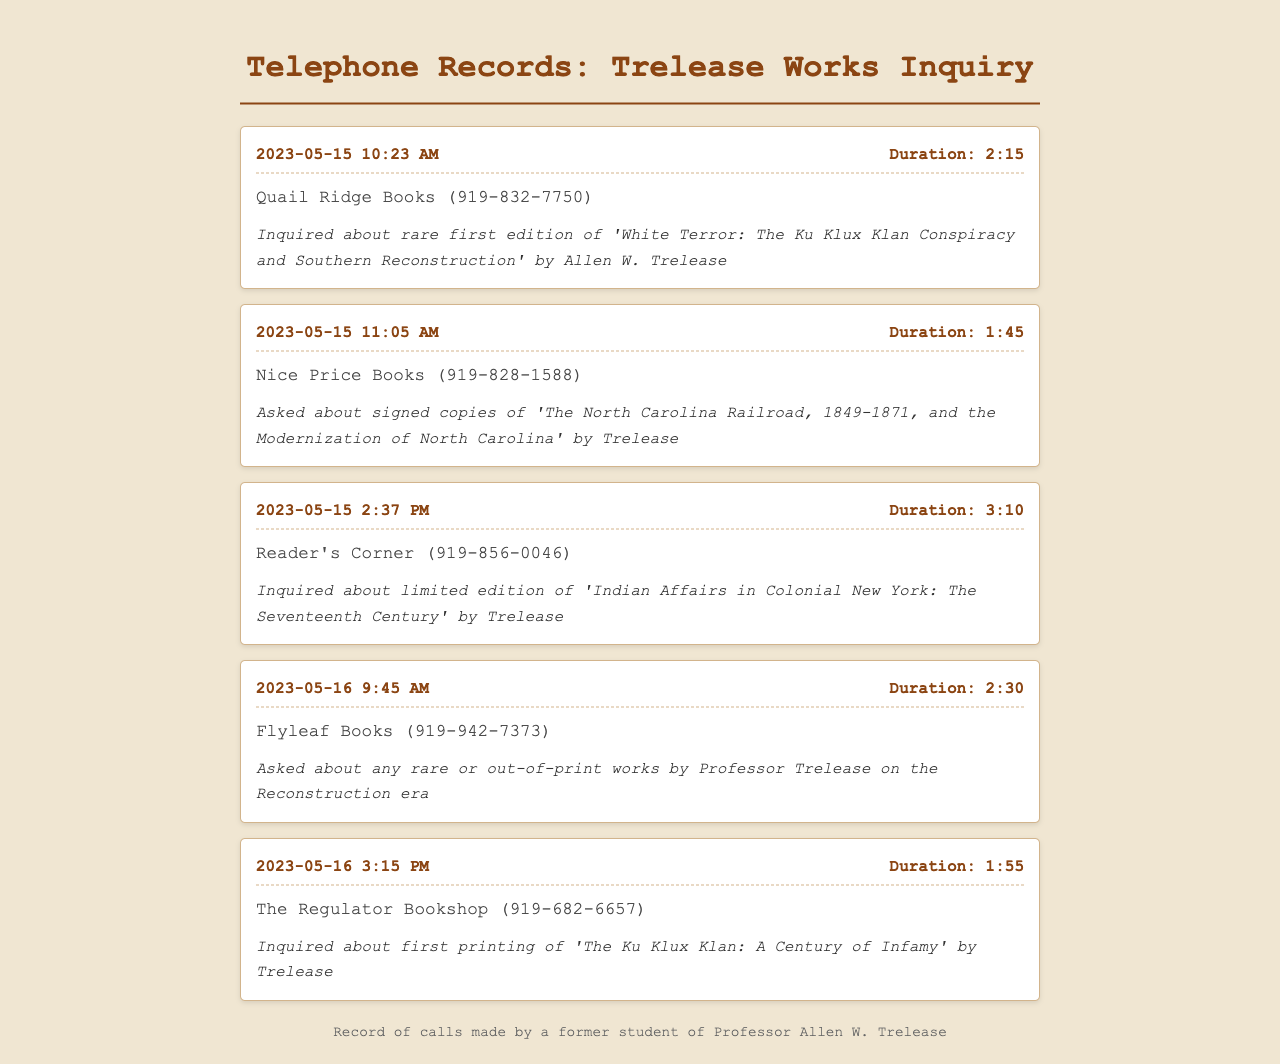What is the date of the first call? The first call listed in the telephone records is on May 15, 2023.
Answer: May 15, 2023 How long was the call to Quail Ridge Books? The duration of the call to Quail Ridge Books is captured in the record. It states the duration is 2 minutes and 15 seconds.
Answer: 2:15 Which bookstore was called last? The last entry in the telephone records indicates the final call made was to The Regulator Bookshop.
Answer: The Regulator Bookshop What was inquired about during the call to Flyleaf Books? The notes section of the Flyleaf Books entry specifies that a query was made about rare or out-of-print works by Professor Trelease.
Answer: Rare or out-of-print works How many calls were made on May 16, 2023? The records show two calls made on May 16, 2023, to different bookstores.
Answer: 2 What is the total duration of the calls made to Nice Price Books? The entry for Nice Price Books indicates the call lasted 1 minute and 45 seconds.
Answer: 1:45 Which book's first edition was inquired about at Quail Ridge Books? The specific book mentioned in the inquiry at Quail Ridge Books is 'White Terror: The Ku Klux Klan Conspiracy and Southern Reconstruction'.
Answer: White Terror: The Ku Klux Klan Conspiracy and Southern Reconstruction What is the phone number for Reader's Corner? The phone number listed for Reader's Corner is 919-856-0046.
Answer: 919-856-0046 What type of works was mentioned in the inquiry to The Regulator Bookshop? The inquiry at The Regulator Bookshop specifically concerned the first printing of a specific book by Trelease.
Answer: First printing 